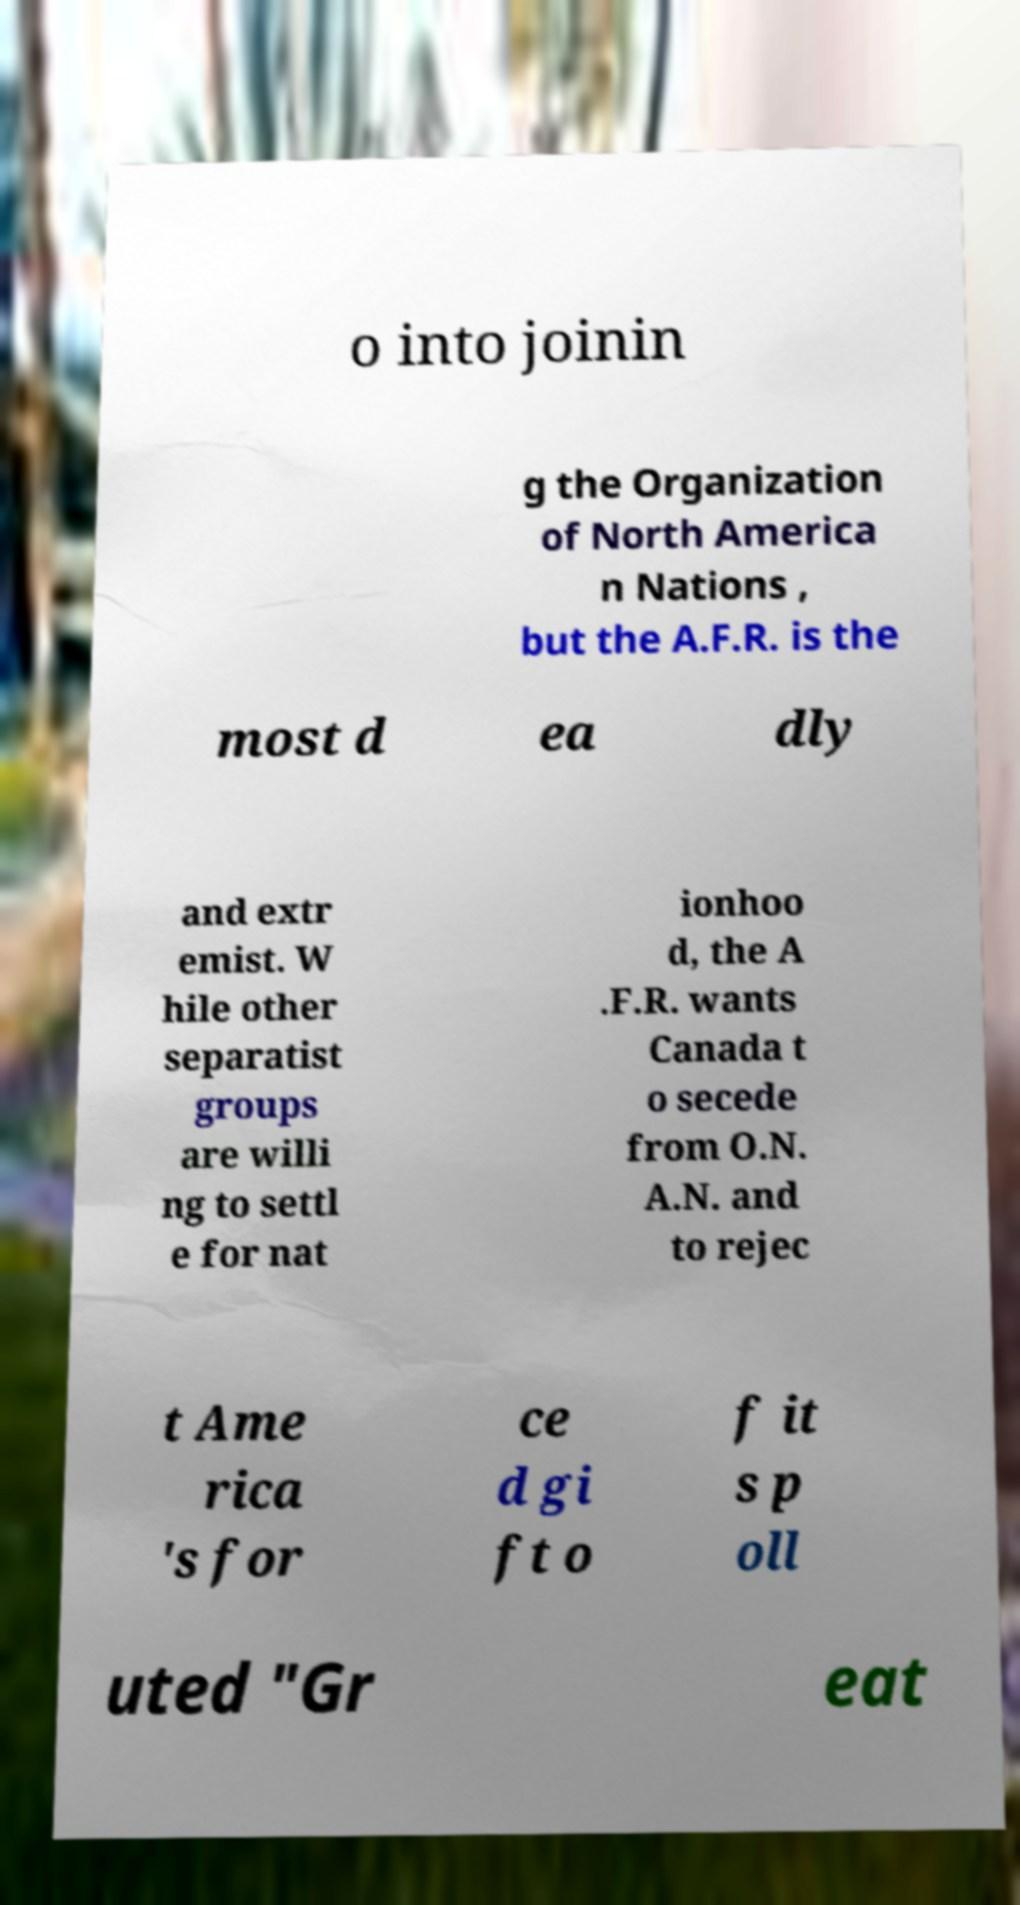Can you accurately transcribe the text from the provided image for me? o into joinin g the Organization of North America n Nations , but the A.F.R. is the most d ea dly and extr emist. W hile other separatist groups are willi ng to settl e for nat ionhoo d, the A .F.R. wants Canada t o secede from O.N. A.N. and to rejec t Ame rica 's for ce d gi ft o f it s p oll uted "Gr eat 